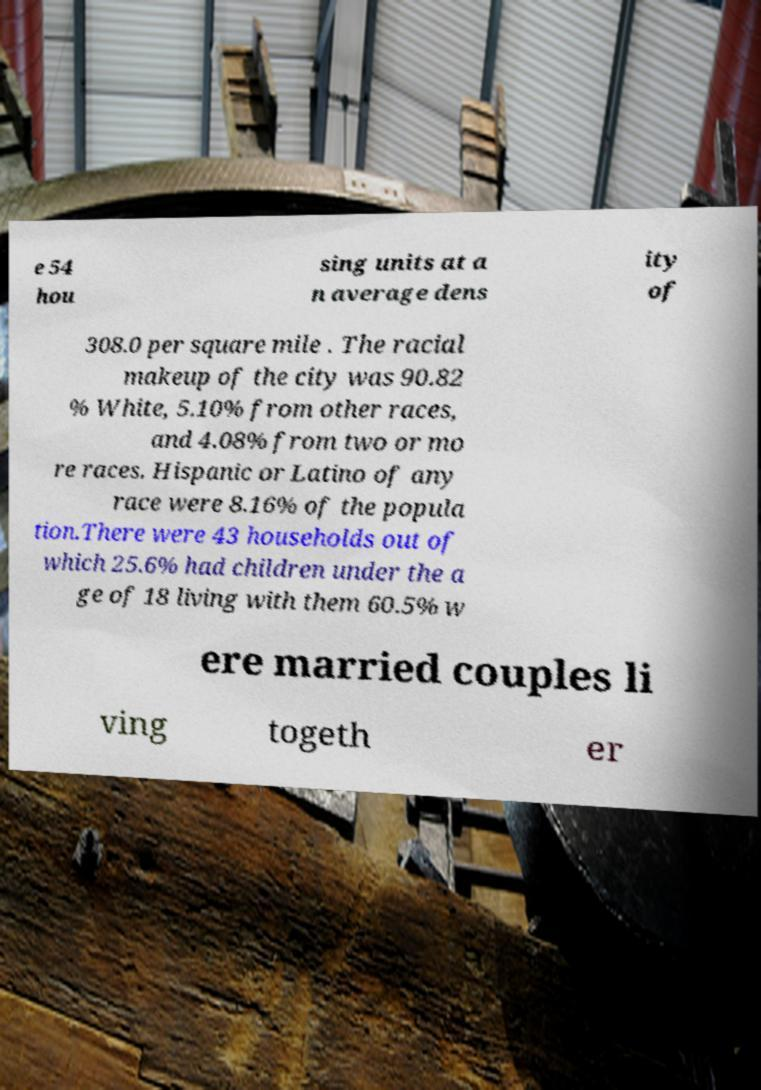What messages or text are displayed in this image? I need them in a readable, typed format. e 54 hou sing units at a n average dens ity of 308.0 per square mile . The racial makeup of the city was 90.82 % White, 5.10% from other races, and 4.08% from two or mo re races. Hispanic or Latino of any race were 8.16% of the popula tion.There were 43 households out of which 25.6% had children under the a ge of 18 living with them 60.5% w ere married couples li ving togeth er 